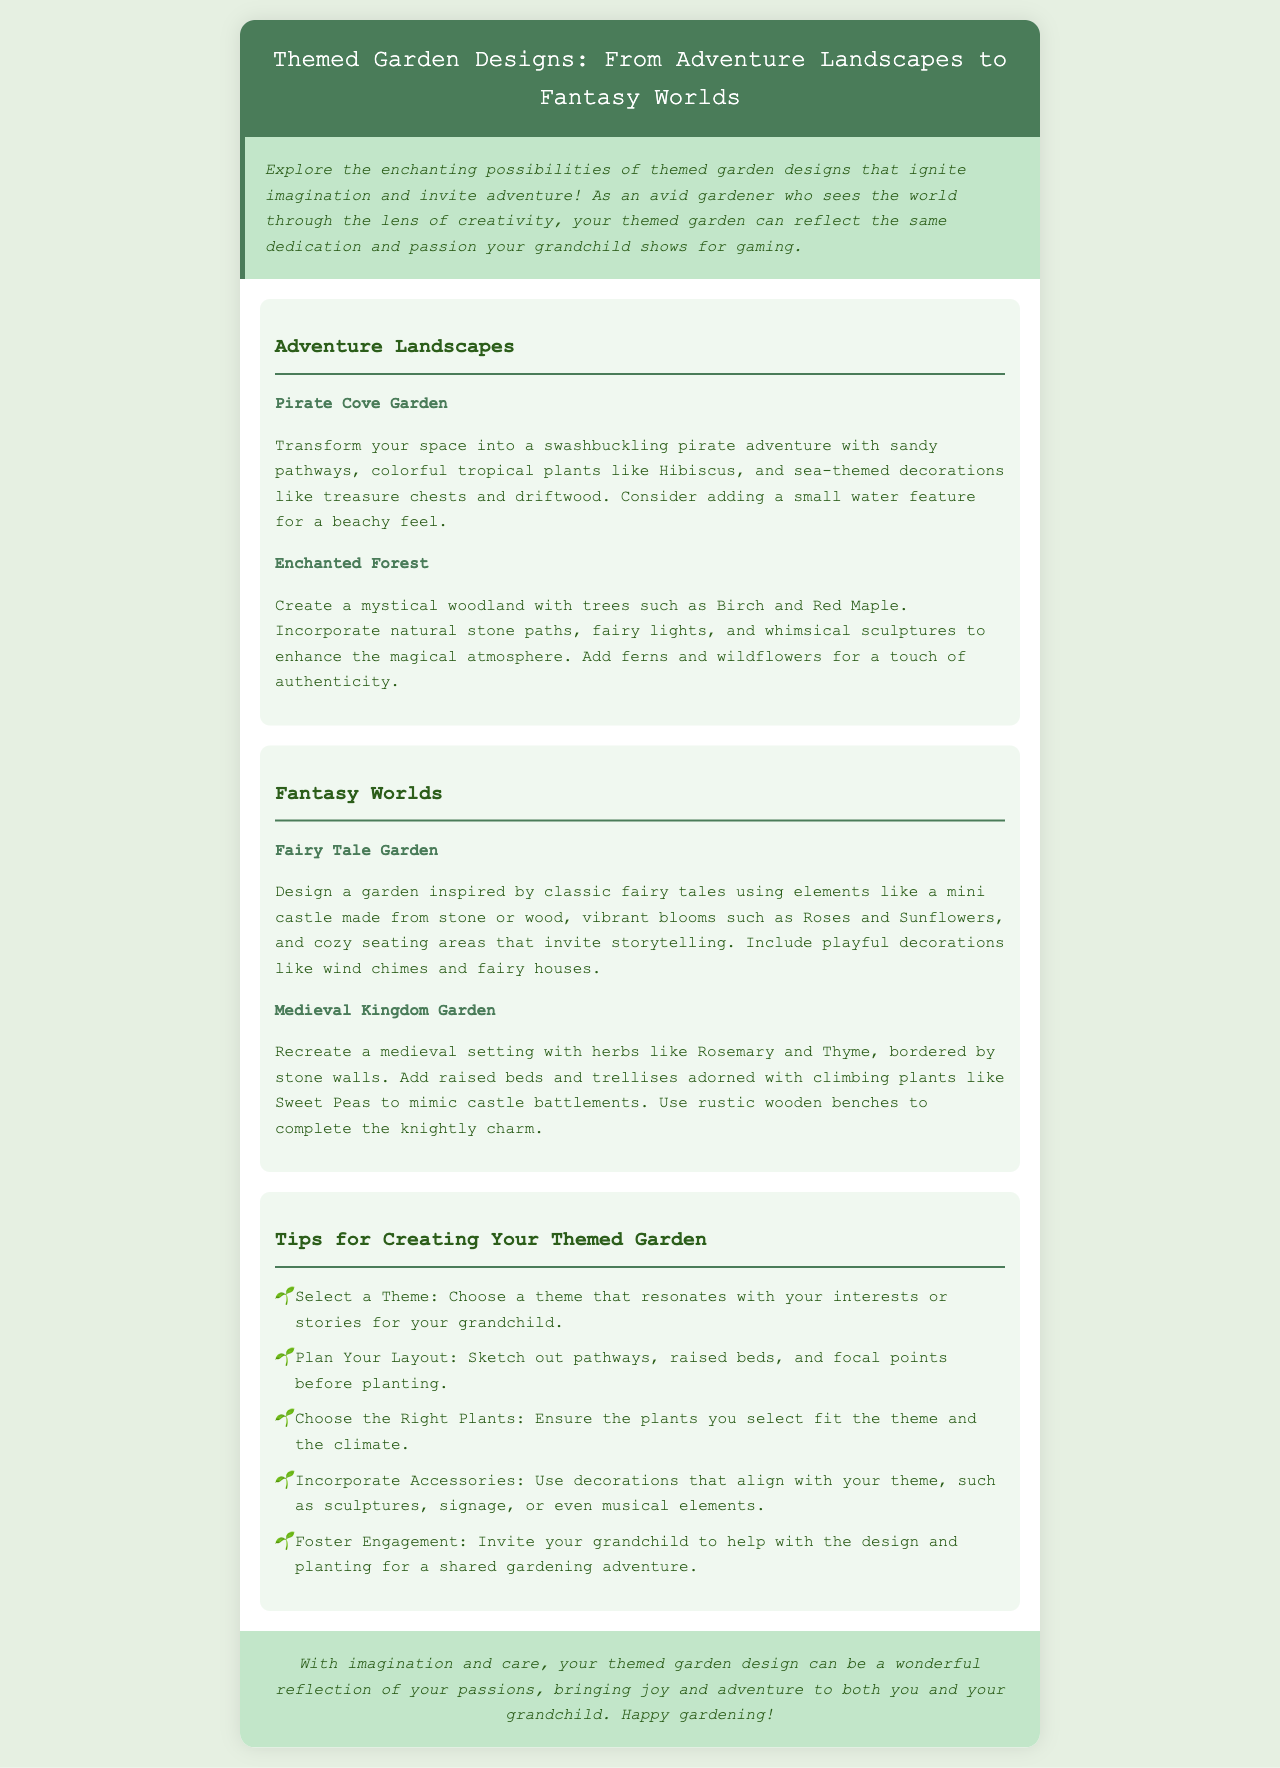What is the title of the brochure? The title of the brochure is found in the header section, which introduces the theme of the document.
Answer: Themed Garden Designs: From Adventure Landscapes to Fantasy Worlds What plant is suggested for the Pirate Cove Garden? The brochure lists specific plants for each themed garden, and Hibiscus is one highlighted for the Pirate Cove Garden.
Answer: Hibiscus What types of gardens are mentioned under Adventure Landscapes? By reviewing the sections under Adventure Landscapes, we can identify the specific garden types presented.
Answer: Pirate Cove Garden, Enchanted Forest How many tips are provided for creating your themed garden? The document lists several guidelines, specifically noted in the section dedicated to tips for themed gardening.
Answer: Five What is a decorative item suggested for the Fairy Tale Garden? Looking into the Fairy Tale Garden description, we can find examples of decor that can be included in the design.
Answer: Wind chimes Which herb is found in the Medieval Kingdom Garden? The brochure provides specific herb choices for different themed gardens, and Rosemary is mentioned for the Medieval Kingdom Garden.
Answer: Rosemary What should you invite your grandchild to do in the garden? The document emphasizes engaging one's grandchild, specifically suggesting involvement in the gardening process.
Answer: Help with the design and planting What color is the background of the brochure? The background color is described at the start of the document, providing context to the aesthetic presentation.
Answer: Light green 